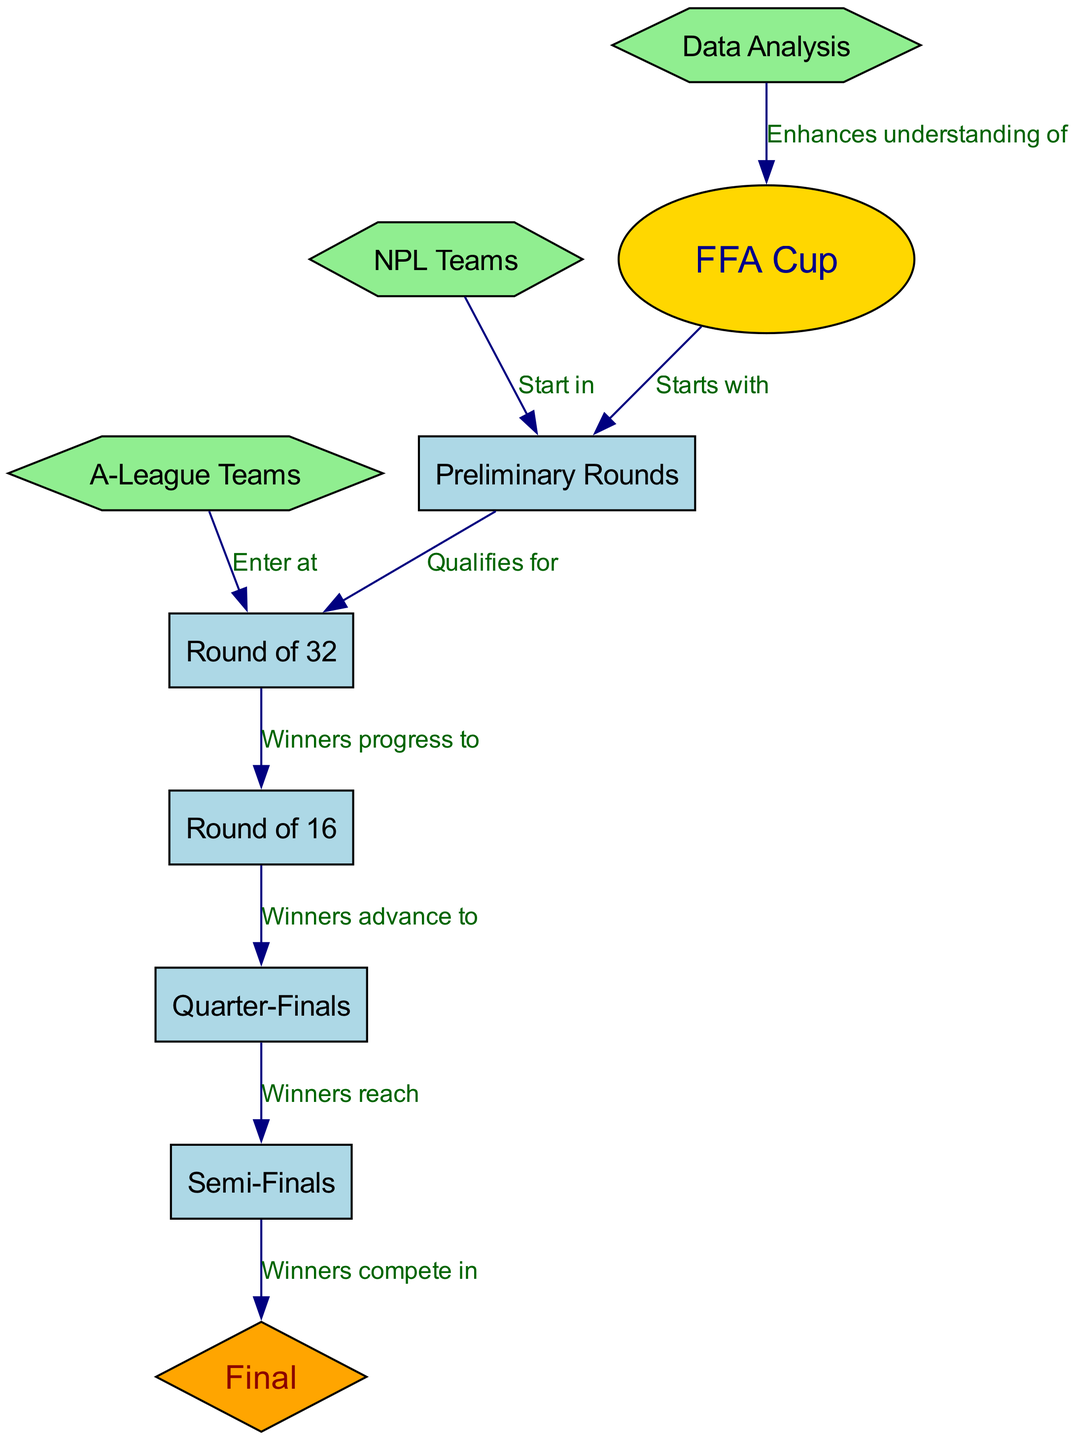What starts the FFA Cup tournament structure? The diagram indicates that the FFA Cup tournament structure begins with the "Preliminary Rounds." This is shown by the directed edge labeled "Starts with" from "FFA Cup" to "Preliminary Rounds."
Answer: Preliminary Rounds In which round do A-League teams enter the tournament? According to the diagram, A-League teams enter the tournament at the "Round of 32." This is indicated by the edge that leads from "A-League Teams" to "Round of 32" labeled "Enter at."
Answer: Round of 32 What is the last stage of progression in the FFA Cup? The final stage of progression in the FFA Cup, as depicted in the diagram, is the "Final." This is indicated by the edge leading to "Final" from "Semi-Finals."
Answer: Final How many total progression stages are in the FFA Cup after the Preliminary Rounds? The progression stages in the FFA Cup after the Preliminary Rounds are "Round of 32," "Round of 16," "Quarter-Finals," "Semi-Finals," and "Final." Counting these gives us a total of five stages.
Answer: 5 What do winners of the Quarter-Finals reach? The diagram shows that the winners of the Quarter-Finals advance to the "Semi-Finals." This is confirmed by the edge labeled "Winners reach" leading from "Quarter-Finals" to "Semi-Finals."
Answer: Semi-Finals What role does Data Analysis play in relation to the FFA Cup? The diagram specifies that Data Analysis enhances the understanding of the FFA Cup, as indicated by the edge that goes from "Data Analysis" to "FFA Cup" labeled "Enhances understanding of."
Answer: Enhances understanding of Where do NPL teams start in the tournament? As shown in the diagram, NPL teams start in the "Preliminary Rounds." This is indicated by the edge leading from "NPL Teams" to "Preliminary Rounds" labeled "Start in."
Answer: Preliminary Rounds How do teams progress from the Round of 16? Teams that win in the Round of 16 will progress to the "Quarter-Finals." This is connected by the edge labeled "Winners advance to" which leads from "Round of 16" to "Quarter-Finals."
Answer: Quarter-Finals 